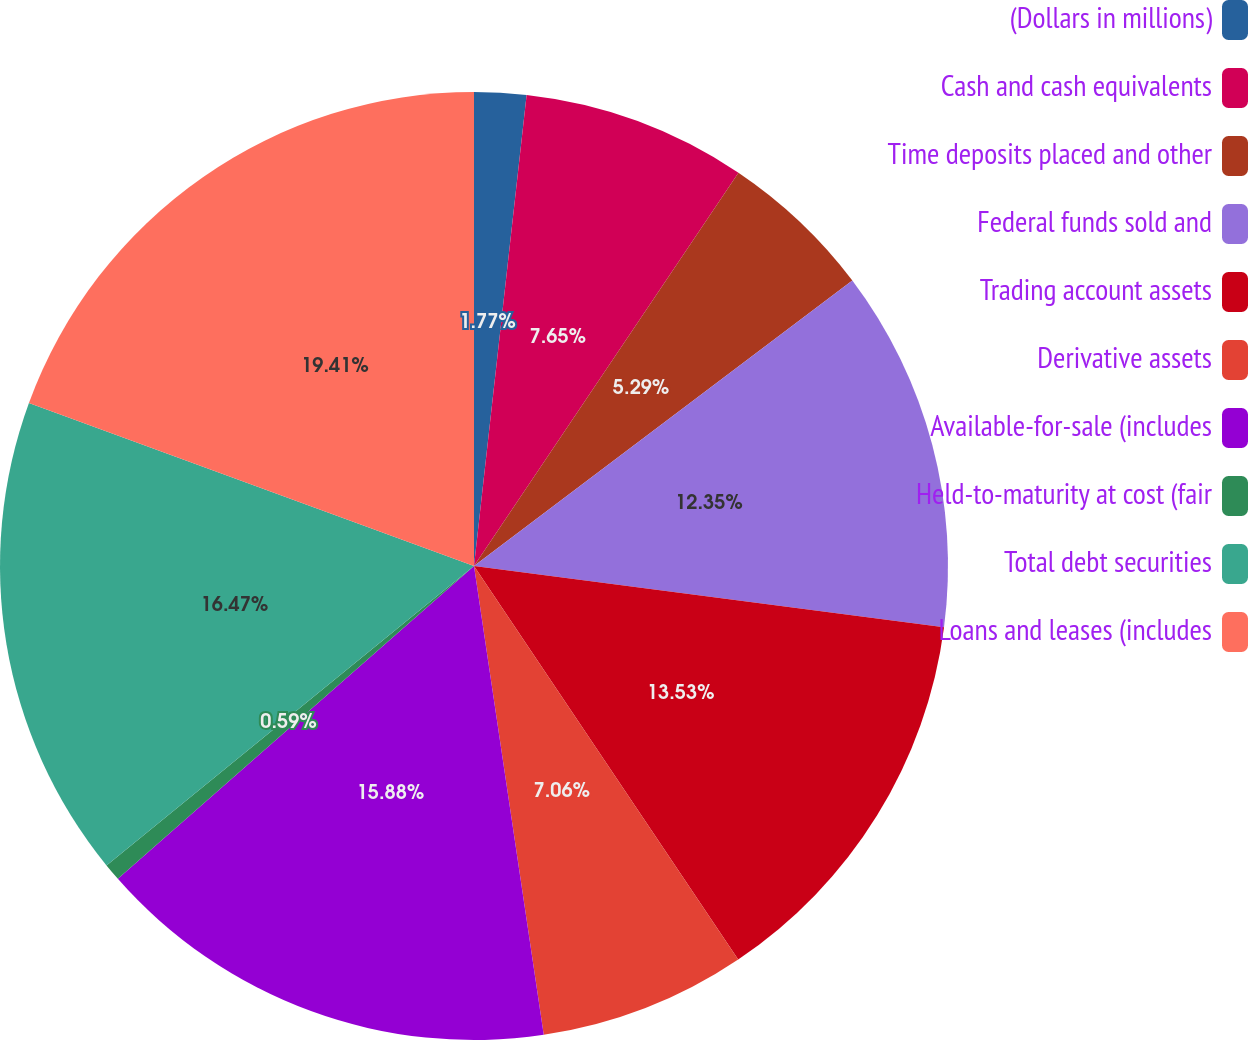<chart> <loc_0><loc_0><loc_500><loc_500><pie_chart><fcel>(Dollars in millions)<fcel>Cash and cash equivalents<fcel>Time deposits placed and other<fcel>Federal funds sold and<fcel>Trading account assets<fcel>Derivative assets<fcel>Available-for-sale (includes<fcel>Held-to-maturity at cost (fair<fcel>Total debt securities<fcel>Loans and leases (includes<nl><fcel>1.77%<fcel>7.65%<fcel>5.29%<fcel>12.35%<fcel>13.53%<fcel>7.06%<fcel>15.88%<fcel>0.59%<fcel>16.47%<fcel>19.41%<nl></chart> 